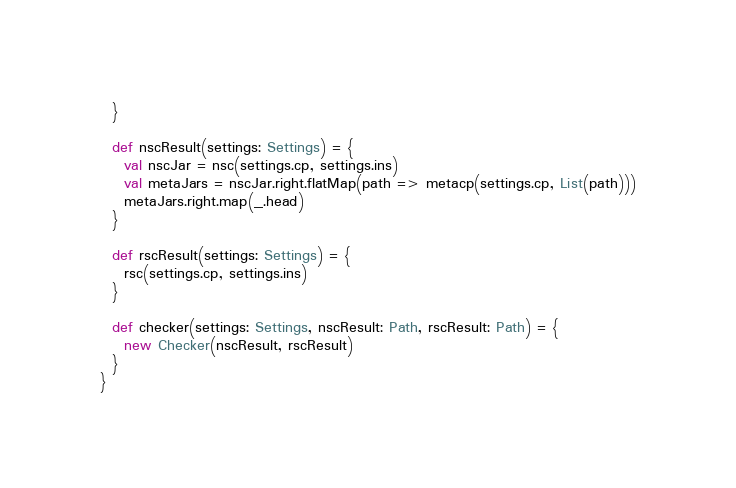Convert code to text. <code><loc_0><loc_0><loc_500><loc_500><_Scala_>  }

  def nscResult(settings: Settings) = {
    val nscJar = nsc(settings.cp, settings.ins)
    val metaJars = nscJar.right.flatMap(path => metacp(settings.cp, List(path)))
    metaJars.right.map(_.head)
  }

  def rscResult(settings: Settings) = {
    rsc(settings.cp, settings.ins)
  }

  def checker(settings: Settings, nscResult: Path, rscResult: Path) = {
    new Checker(nscResult, rscResult)
  }
}
</code> 